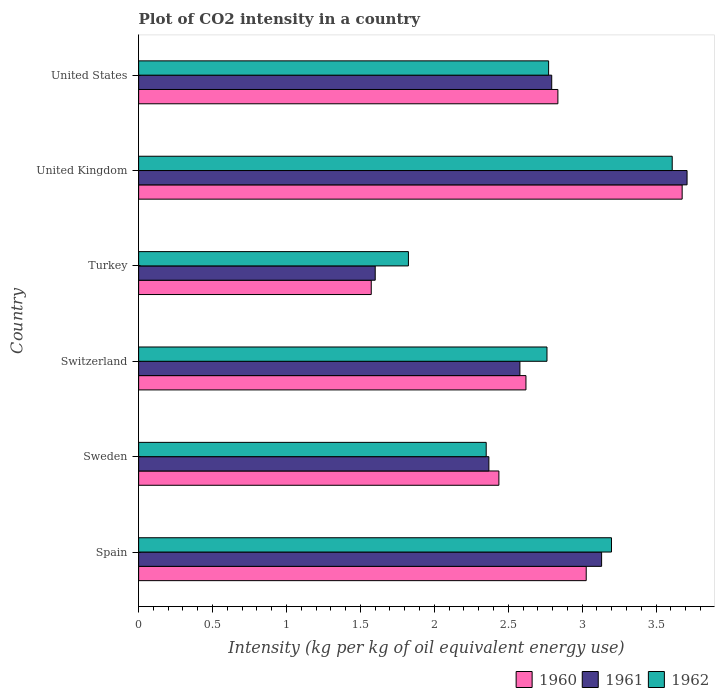How many different coloured bars are there?
Your answer should be very brief. 3. Are the number of bars per tick equal to the number of legend labels?
Offer a very short reply. Yes. Are the number of bars on each tick of the Y-axis equal?
Your response must be concise. Yes. How many bars are there on the 6th tick from the top?
Your answer should be very brief. 3. What is the CO2 intensity in in 1962 in United States?
Offer a very short reply. 2.77. Across all countries, what is the maximum CO2 intensity in in 1962?
Your answer should be very brief. 3.61. Across all countries, what is the minimum CO2 intensity in in 1961?
Provide a succinct answer. 1.6. In which country was the CO2 intensity in in 1961 maximum?
Your answer should be compact. United Kingdom. What is the total CO2 intensity in in 1962 in the graph?
Ensure brevity in your answer.  16.52. What is the difference between the CO2 intensity in in 1961 in Spain and that in United States?
Offer a very short reply. 0.34. What is the difference between the CO2 intensity in in 1960 in United Kingdom and the CO2 intensity in in 1961 in Switzerland?
Your response must be concise. 1.1. What is the average CO2 intensity in in 1961 per country?
Your answer should be very brief. 2.7. What is the difference between the CO2 intensity in in 1961 and CO2 intensity in in 1960 in Switzerland?
Provide a succinct answer. -0.04. In how many countries, is the CO2 intensity in in 1962 greater than 1.7 kg?
Make the answer very short. 6. What is the ratio of the CO2 intensity in in 1962 in Switzerland to that in United States?
Ensure brevity in your answer.  1. Is the CO2 intensity in in 1962 in Switzerland less than that in United States?
Provide a short and direct response. Yes. What is the difference between the highest and the second highest CO2 intensity in in 1961?
Offer a very short reply. 0.58. What is the difference between the highest and the lowest CO2 intensity in in 1960?
Your answer should be very brief. 2.1. In how many countries, is the CO2 intensity in in 1961 greater than the average CO2 intensity in in 1961 taken over all countries?
Ensure brevity in your answer.  3. Is the sum of the CO2 intensity in in 1961 in Sweden and United States greater than the maximum CO2 intensity in in 1960 across all countries?
Offer a very short reply. Yes. What does the 1st bar from the top in Sweden represents?
Provide a short and direct response. 1962. What does the 1st bar from the bottom in United Kingdom represents?
Offer a terse response. 1960. Is it the case that in every country, the sum of the CO2 intensity in in 1962 and CO2 intensity in in 1960 is greater than the CO2 intensity in in 1961?
Provide a succinct answer. Yes. Are all the bars in the graph horizontal?
Provide a short and direct response. Yes. How many countries are there in the graph?
Ensure brevity in your answer.  6. What is the difference between two consecutive major ticks on the X-axis?
Give a very brief answer. 0.5. Are the values on the major ticks of X-axis written in scientific E-notation?
Provide a succinct answer. No. Does the graph contain any zero values?
Offer a very short reply. No. Does the graph contain grids?
Offer a very short reply. No. Where does the legend appear in the graph?
Your answer should be very brief. Bottom right. How many legend labels are there?
Keep it short and to the point. 3. What is the title of the graph?
Your answer should be compact. Plot of CO2 intensity in a country. Does "1981" appear as one of the legend labels in the graph?
Give a very brief answer. No. What is the label or title of the X-axis?
Your response must be concise. Intensity (kg per kg of oil equivalent energy use). What is the Intensity (kg per kg of oil equivalent energy use) of 1960 in Spain?
Ensure brevity in your answer.  3.03. What is the Intensity (kg per kg of oil equivalent energy use) in 1961 in Spain?
Your response must be concise. 3.13. What is the Intensity (kg per kg of oil equivalent energy use) of 1962 in Spain?
Your answer should be very brief. 3.2. What is the Intensity (kg per kg of oil equivalent energy use) in 1960 in Sweden?
Ensure brevity in your answer.  2.44. What is the Intensity (kg per kg of oil equivalent energy use) in 1961 in Sweden?
Keep it short and to the point. 2.37. What is the Intensity (kg per kg of oil equivalent energy use) of 1962 in Sweden?
Your response must be concise. 2.35. What is the Intensity (kg per kg of oil equivalent energy use) in 1960 in Switzerland?
Offer a very short reply. 2.62. What is the Intensity (kg per kg of oil equivalent energy use) in 1961 in Switzerland?
Offer a terse response. 2.58. What is the Intensity (kg per kg of oil equivalent energy use) in 1962 in Switzerland?
Offer a terse response. 2.76. What is the Intensity (kg per kg of oil equivalent energy use) of 1960 in Turkey?
Your response must be concise. 1.57. What is the Intensity (kg per kg of oil equivalent energy use) in 1961 in Turkey?
Offer a very short reply. 1.6. What is the Intensity (kg per kg of oil equivalent energy use) in 1962 in Turkey?
Your answer should be compact. 1.82. What is the Intensity (kg per kg of oil equivalent energy use) in 1960 in United Kingdom?
Offer a terse response. 3.68. What is the Intensity (kg per kg of oil equivalent energy use) in 1961 in United Kingdom?
Your answer should be compact. 3.71. What is the Intensity (kg per kg of oil equivalent energy use) of 1962 in United Kingdom?
Make the answer very short. 3.61. What is the Intensity (kg per kg of oil equivalent energy use) in 1960 in United States?
Your answer should be compact. 2.84. What is the Intensity (kg per kg of oil equivalent energy use) in 1961 in United States?
Provide a succinct answer. 2.79. What is the Intensity (kg per kg of oil equivalent energy use) in 1962 in United States?
Keep it short and to the point. 2.77. Across all countries, what is the maximum Intensity (kg per kg of oil equivalent energy use) in 1960?
Offer a very short reply. 3.68. Across all countries, what is the maximum Intensity (kg per kg of oil equivalent energy use) of 1961?
Your response must be concise. 3.71. Across all countries, what is the maximum Intensity (kg per kg of oil equivalent energy use) in 1962?
Your answer should be compact. 3.61. Across all countries, what is the minimum Intensity (kg per kg of oil equivalent energy use) in 1960?
Provide a short and direct response. 1.57. Across all countries, what is the minimum Intensity (kg per kg of oil equivalent energy use) of 1961?
Keep it short and to the point. 1.6. Across all countries, what is the minimum Intensity (kg per kg of oil equivalent energy use) of 1962?
Ensure brevity in your answer.  1.82. What is the total Intensity (kg per kg of oil equivalent energy use) of 1960 in the graph?
Provide a short and direct response. 16.17. What is the total Intensity (kg per kg of oil equivalent energy use) of 1961 in the graph?
Provide a succinct answer. 16.18. What is the total Intensity (kg per kg of oil equivalent energy use) in 1962 in the graph?
Keep it short and to the point. 16.52. What is the difference between the Intensity (kg per kg of oil equivalent energy use) of 1960 in Spain and that in Sweden?
Provide a succinct answer. 0.59. What is the difference between the Intensity (kg per kg of oil equivalent energy use) in 1961 in Spain and that in Sweden?
Offer a very short reply. 0.76. What is the difference between the Intensity (kg per kg of oil equivalent energy use) in 1962 in Spain and that in Sweden?
Give a very brief answer. 0.85. What is the difference between the Intensity (kg per kg of oil equivalent energy use) in 1960 in Spain and that in Switzerland?
Provide a succinct answer. 0.41. What is the difference between the Intensity (kg per kg of oil equivalent energy use) of 1961 in Spain and that in Switzerland?
Provide a short and direct response. 0.55. What is the difference between the Intensity (kg per kg of oil equivalent energy use) in 1962 in Spain and that in Switzerland?
Keep it short and to the point. 0.44. What is the difference between the Intensity (kg per kg of oil equivalent energy use) of 1960 in Spain and that in Turkey?
Offer a very short reply. 1.45. What is the difference between the Intensity (kg per kg of oil equivalent energy use) of 1961 in Spain and that in Turkey?
Provide a succinct answer. 1.53. What is the difference between the Intensity (kg per kg of oil equivalent energy use) in 1962 in Spain and that in Turkey?
Provide a succinct answer. 1.37. What is the difference between the Intensity (kg per kg of oil equivalent energy use) in 1960 in Spain and that in United Kingdom?
Make the answer very short. -0.65. What is the difference between the Intensity (kg per kg of oil equivalent energy use) of 1961 in Spain and that in United Kingdom?
Keep it short and to the point. -0.58. What is the difference between the Intensity (kg per kg of oil equivalent energy use) of 1962 in Spain and that in United Kingdom?
Your answer should be compact. -0.41. What is the difference between the Intensity (kg per kg of oil equivalent energy use) in 1960 in Spain and that in United States?
Your response must be concise. 0.19. What is the difference between the Intensity (kg per kg of oil equivalent energy use) in 1961 in Spain and that in United States?
Your answer should be compact. 0.34. What is the difference between the Intensity (kg per kg of oil equivalent energy use) in 1962 in Spain and that in United States?
Offer a terse response. 0.43. What is the difference between the Intensity (kg per kg of oil equivalent energy use) of 1960 in Sweden and that in Switzerland?
Give a very brief answer. -0.18. What is the difference between the Intensity (kg per kg of oil equivalent energy use) of 1961 in Sweden and that in Switzerland?
Offer a terse response. -0.21. What is the difference between the Intensity (kg per kg of oil equivalent energy use) in 1962 in Sweden and that in Switzerland?
Your answer should be compact. -0.41. What is the difference between the Intensity (kg per kg of oil equivalent energy use) of 1960 in Sweden and that in Turkey?
Keep it short and to the point. 0.86. What is the difference between the Intensity (kg per kg of oil equivalent energy use) in 1961 in Sweden and that in Turkey?
Your answer should be compact. 0.77. What is the difference between the Intensity (kg per kg of oil equivalent energy use) of 1962 in Sweden and that in Turkey?
Offer a terse response. 0.53. What is the difference between the Intensity (kg per kg of oil equivalent energy use) of 1960 in Sweden and that in United Kingdom?
Keep it short and to the point. -1.24. What is the difference between the Intensity (kg per kg of oil equivalent energy use) in 1961 in Sweden and that in United Kingdom?
Offer a terse response. -1.34. What is the difference between the Intensity (kg per kg of oil equivalent energy use) in 1962 in Sweden and that in United Kingdom?
Give a very brief answer. -1.26. What is the difference between the Intensity (kg per kg of oil equivalent energy use) of 1960 in Sweden and that in United States?
Your answer should be very brief. -0.4. What is the difference between the Intensity (kg per kg of oil equivalent energy use) of 1961 in Sweden and that in United States?
Your answer should be very brief. -0.43. What is the difference between the Intensity (kg per kg of oil equivalent energy use) of 1962 in Sweden and that in United States?
Ensure brevity in your answer.  -0.42. What is the difference between the Intensity (kg per kg of oil equivalent energy use) of 1960 in Switzerland and that in Turkey?
Make the answer very short. 1.05. What is the difference between the Intensity (kg per kg of oil equivalent energy use) of 1961 in Switzerland and that in Turkey?
Your response must be concise. 0.98. What is the difference between the Intensity (kg per kg of oil equivalent energy use) of 1962 in Switzerland and that in Turkey?
Your response must be concise. 0.94. What is the difference between the Intensity (kg per kg of oil equivalent energy use) in 1960 in Switzerland and that in United Kingdom?
Offer a terse response. -1.06. What is the difference between the Intensity (kg per kg of oil equivalent energy use) in 1961 in Switzerland and that in United Kingdom?
Your answer should be very brief. -1.13. What is the difference between the Intensity (kg per kg of oil equivalent energy use) in 1962 in Switzerland and that in United Kingdom?
Offer a terse response. -0.85. What is the difference between the Intensity (kg per kg of oil equivalent energy use) in 1960 in Switzerland and that in United States?
Ensure brevity in your answer.  -0.22. What is the difference between the Intensity (kg per kg of oil equivalent energy use) in 1961 in Switzerland and that in United States?
Provide a short and direct response. -0.22. What is the difference between the Intensity (kg per kg of oil equivalent energy use) in 1962 in Switzerland and that in United States?
Provide a short and direct response. -0.01. What is the difference between the Intensity (kg per kg of oil equivalent energy use) in 1960 in Turkey and that in United Kingdom?
Offer a terse response. -2.1. What is the difference between the Intensity (kg per kg of oil equivalent energy use) in 1961 in Turkey and that in United Kingdom?
Make the answer very short. -2.11. What is the difference between the Intensity (kg per kg of oil equivalent energy use) of 1962 in Turkey and that in United Kingdom?
Offer a very short reply. -1.78. What is the difference between the Intensity (kg per kg of oil equivalent energy use) of 1960 in Turkey and that in United States?
Your answer should be very brief. -1.26. What is the difference between the Intensity (kg per kg of oil equivalent energy use) of 1961 in Turkey and that in United States?
Your response must be concise. -1.19. What is the difference between the Intensity (kg per kg of oil equivalent energy use) of 1962 in Turkey and that in United States?
Offer a terse response. -0.95. What is the difference between the Intensity (kg per kg of oil equivalent energy use) of 1960 in United Kingdom and that in United States?
Ensure brevity in your answer.  0.84. What is the difference between the Intensity (kg per kg of oil equivalent energy use) of 1961 in United Kingdom and that in United States?
Your response must be concise. 0.92. What is the difference between the Intensity (kg per kg of oil equivalent energy use) of 1962 in United Kingdom and that in United States?
Offer a very short reply. 0.84. What is the difference between the Intensity (kg per kg of oil equivalent energy use) of 1960 in Spain and the Intensity (kg per kg of oil equivalent energy use) of 1961 in Sweden?
Offer a very short reply. 0.66. What is the difference between the Intensity (kg per kg of oil equivalent energy use) of 1960 in Spain and the Intensity (kg per kg of oil equivalent energy use) of 1962 in Sweden?
Make the answer very short. 0.68. What is the difference between the Intensity (kg per kg of oil equivalent energy use) in 1961 in Spain and the Intensity (kg per kg of oil equivalent energy use) in 1962 in Sweden?
Provide a succinct answer. 0.78. What is the difference between the Intensity (kg per kg of oil equivalent energy use) of 1960 in Spain and the Intensity (kg per kg of oil equivalent energy use) of 1961 in Switzerland?
Offer a very short reply. 0.45. What is the difference between the Intensity (kg per kg of oil equivalent energy use) of 1960 in Spain and the Intensity (kg per kg of oil equivalent energy use) of 1962 in Switzerland?
Your response must be concise. 0.27. What is the difference between the Intensity (kg per kg of oil equivalent energy use) of 1961 in Spain and the Intensity (kg per kg of oil equivalent energy use) of 1962 in Switzerland?
Make the answer very short. 0.37. What is the difference between the Intensity (kg per kg of oil equivalent energy use) in 1960 in Spain and the Intensity (kg per kg of oil equivalent energy use) in 1961 in Turkey?
Your response must be concise. 1.43. What is the difference between the Intensity (kg per kg of oil equivalent energy use) of 1960 in Spain and the Intensity (kg per kg of oil equivalent energy use) of 1962 in Turkey?
Keep it short and to the point. 1.2. What is the difference between the Intensity (kg per kg of oil equivalent energy use) in 1961 in Spain and the Intensity (kg per kg of oil equivalent energy use) in 1962 in Turkey?
Your answer should be very brief. 1.31. What is the difference between the Intensity (kg per kg of oil equivalent energy use) of 1960 in Spain and the Intensity (kg per kg of oil equivalent energy use) of 1961 in United Kingdom?
Give a very brief answer. -0.68. What is the difference between the Intensity (kg per kg of oil equivalent energy use) in 1960 in Spain and the Intensity (kg per kg of oil equivalent energy use) in 1962 in United Kingdom?
Your answer should be compact. -0.58. What is the difference between the Intensity (kg per kg of oil equivalent energy use) of 1961 in Spain and the Intensity (kg per kg of oil equivalent energy use) of 1962 in United Kingdom?
Provide a short and direct response. -0.48. What is the difference between the Intensity (kg per kg of oil equivalent energy use) of 1960 in Spain and the Intensity (kg per kg of oil equivalent energy use) of 1961 in United States?
Provide a short and direct response. 0.23. What is the difference between the Intensity (kg per kg of oil equivalent energy use) of 1960 in Spain and the Intensity (kg per kg of oil equivalent energy use) of 1962 in United States?
Offer a terse response. 0.25. What is the difference between the Intensity (kg per kg of oil equivalent energy use) in 1961 in Spain and the Intensity (kg per kg of oil equivalent energy use) in 1962 in United States?
Provide a succinct answer. 0.36. What is the difference between the Intensity (kg per kg of oil equivalent energy use) in 1960 in Sweden and the Intensity (kg per kg of oil equivalent energy use) in 1961 in Switzerland?
Your answer should be very brief. -0.14. What is the difference between the Intensity (kg per kg of oil equivalent energy use) in 1960 in Sweden and the Intensity (kg per kg of oil equivalent energy use) in 1962 in Switzerland?
Ensure brevity in your answer.  -0.33. What is the difference between the Intensity (kg per kg of oil equivalent energy use) of 1961 in Sweden and the Intensity (kg per kg of oil equivalent energy use) of 1962 in Switzerland?
Your response must be concise. -0.39. What is the difference between the Intensity (kg per kg of oil equivalent energy use) of 1960 in Sweden and the Intensity (kg per kg of oil equivalent energy use) of 1961 in Turkey?
Provide a short and direct response. 0.84. What is the difference between the Intensity (kg per kg of oil equivalent energy use) in 1960 in Sweden and the Intensity (kg per kg of oil equivalent energy use) in 1962 in Turkey?
Your response must be concise. 0.61. What is the difference between the Intensity (kg per kg of oil equivalent energy use) in 1961 in Sweden and the Intensity (kg per kg of oil equivalent energy use) in 1962 in Turkey?
Offer a very short reply. 0.54. What is the difference between the Intensity (kg per kg of oil equivalent energy use) in 1960 in Sweden and the Intensity (kg per kg of oil equivalent energy use) in 1961 in United Kingdom?
Give a very brief answer. -1.27. What is the difference between the Intensity (kg per kg of oil equivalent energy use) in 1960 in Sweden and the Intensity (kg per kg of oil equivalent energy use) in 1962 in United Kingdom?
Your answer should be compact. -1.17. What is the difference between the Intensity (kg per kg of oil equivalent energy use) of 1961 in Sweden and the Intensity (kg per kg of oil equivalent energy use) of 1962 in United Kingdom?
Offer a very short reply. -1.24. What is the difference between the Intensity (kg per kg of oil equivalent energy use) of 1960 in Sweden and the Intensity (kg per kg of oil equivalent energy use) of 1961 in United States?
Keep it short and to the point. -0.36. What is the difference between the Intensity (kg per kg of oil equivalent energy use) of 1960 in Sweden and the Intensity (kg per kg of oil equivalent energy use) of 1962 in United States?
Your answer should be very brief. -0.34. What is the difference between the Intensity (kg per kg of oil equivalent energy use) in 1961 in Sweden and the Intensity (kg per kg of oil equivalent energy use) in 1962 in United States?
Offer a very short reply. -0.4. What is the difference between the Intensity (kg per kg of oil equivalent energy use) of 1960 in Switzerland and the Intensity (kg per kg of oil equivalent energy use) of 1961 in Turkey?
Provide a short and direct response. 1.02. What is the difference between the Intensity (kg per kg of oil equivalent energy use) of 1960 in Switzerland and the Intensity (kg per kg of oil equivalent energy use) of 1962 in Turkey?
Your answer should be compact. 0.8. What is the difference between the Intensity (kg per kg of oil equivalent energy use) in 1961 in Switzerland and the Intensity (kg per kg of oil equivalent energy use) in 1962 in Turkey?
Offer a terse response. 0.75. What is the difference between the Intensity (kg per kg of oil equivalent energy use) in 1960 in Switzerland and the Intensity (kg per kg of oil equivalent energy use) in 1961 in United Kingdom?
Offer a terse response. -1.09. What is the difference between the Intensity (kg per kg of oil equivalent energy use) in 1960 in Switzerland and the Intensity (kg per kg of oil equivalent energy use) in 1962 in United Kingdom?
Offer a terse response. -0.99. What is the difference between the Intensity (kg per kg of oil equivalent energy use) in 1961 in Switzerland and the Intensity (kg per kg of oil equivalent energy use) in 1962 in United Kingdom?
Your answer should be compact. -1.03. What is the difference between the Intensity (kg per kg of oil equivalent energy use) in 1960 in Switzerland and the Intensity (kg per kg of oil equivalent energy use) in 1961 in United States?
Give a very brief answer. -0.17. What is the difference between the Intensity (kg per kg of oil equivalent energy use) in 1960 in Switzerland and the Intensity (kg per kg of oil equivalent energy use) in 1962 in United States?
Provide a succinct answer. -0.15. What is the difference between the Intensity (kg per kg of oil equivalent energy use) in 1961 in Switzerland and the Intensity (kg per kg of oil equivalent energy use) in 1962 in United States?
Provide a short and direct response. -0.19. What is the difference between the Intensity (kg per kg of oil equivalent energy use) of 1960 in Turkey and the Intensity (kg per kg of oil equivalent energy use) of 1961 in United Kingdom?
Provide a succinct answer. -2.14. What is the difference between the Intensity (kg per kg of oil equivalent energy use) of 1960 in Turkey and the Intensity (kg per kg of oil equivalent energy use) of 1962 in United Kingdom?
Provide a short and direct response. -2.04. What is the difference between the Intensity (kg per kg of oil equivalent energy use) in 1961 in Turkey and the Intensity (kg per kg of oil equivalent energy use) in 1962 in United Kingdom?
Ensure brevity in your answer.  -2.01. What is the difference between the Intensity (kg per kg of oil equivalent energy use) of 1960 in Turkey and the Intensity (kg per kg of oil equivalent energy use) of 1961 in United States?
Keep it short and to the point. -1.22. What is the difference between the Intensity (kg per kg of oil equivalent energy use) of 1960 in Turkey and the Intensity (kg per kg of oil equivalent energy use) of 1962 in United States?
Ensure brevity in your answer.  -1.2. What is the difference between the Intensity (kg per kg of oil equivalent energy use) in 1961 in Turkey and the Intensity (kg per kg of oil equivalent energy use) in 1962 in United States?
Offer a terse response. -1.17. What is the difference between the Intensity (kg per kg of oil equivalent energy use) of 1960 in United Kingdom and the Intensity (kg per kg of oil equivalent energy use) of 1961 in United States?
Offer a terse response. 0.88. What is the difference between the Intensity (kg per kg of oil equivalent energy use) of 1960 in United Kingdom and the Intensity (kg per kg of oil equivalent energy use) of 1962 in United States?
Offer a very short reply. 0.9. What is the difference between the Intensity (kg per kg of oil equivalent energy use) in 1961 in United Kingdom and the Intensity (kg per kg of oil equivalent energy use) in 1962 in United States?
Keep it short and to the point. 0.94. What is the average Intensity (kg per kg of oil equivalent energy use) of 1960 per country?
Give a very brief answer. 2.69. What is the average Intensity (kg per kg of oil equivalent energy use) in 1961 per country?
Offer a very short reply. 2.7. What is the average Intensity (kg per kg of oil equivalent energy use) in 1962 per country?
Ensure brevity in your answer.  2.75. What is the difference between the Intensity (kg per kg of oil equivalent energy use) in 1960 and Intensity (kg per kg of oil equivalent energy use) in 1961 in Spain?
Offer a very short reply. -0.1. What is the difference between the Intensity (kg per kg of oil equivalent energy use) in 1960 and Intensity (kg per kg of oil equivalent energy use) in 1962 in Spain?
Offer a very short reply. -0.17. What is the difference between the Intensity (kg per kg of oil equivalent energy use) in 1961 and Intensity (kg per kg of oil equivalent energy use) in 1962 in Spain?
Offer a very short reply. -0.07. What is the difference between the Intensity (kg per kg of oil equivalent energy use) of 1960 and Intensity (kg per kg of oil equivalent energy use) of 1961 in Sweden?
Provide a succinct answer. 0.07. What is the difference between the Intensity (kg per kg of oil equivalent energy use) in 1960 and Intensity (kg per kg of oil equivalent energy use) in 1962 in Sweden?
Your answer should be compact. 0.09. What is the difference between the Intensity (kg per kg of oil equivalent energy use) of 1961 and Intensity (kg per kg of oil equivalent energy use) of 1962 in Sweden?
Ensure brevity in your answer.  0.02. What is the difference between the Intensity (kg per kg of oil equivalent energy use) of 1960 and Intensity (kg per kg of oil equivalent energy use) of 1961 in Switzerland?
Offer a terse response. 0.04. What is the difference between the Intensity (kg per kg of oil equivalent energy use) of 1960 and Intensity (kg per kg of oil equivalent energy use) of 1962 in Switzerland?
Your answer should be very brief. -0.14. What is the difference between the Intensity (kg per kg of oil equivalent energy use) in 1961 and Intensity (kg per kg of oil equivalent energy use) in 1962 in Switzerland?
Keep it short and to the point. -0.18. What is the difference between the Intensity (kg per kg of oil equivalent energy use) in 1960 and Intensity (kg per kg of oil equivalent energy use) in 1961 in Turkey?
Your response must be concise. -0.03. What is the difference between the Intensity (kg per kg of oil equivalent energy use) in 1960 and Intensity (kg per kg of oil equivalent energy use) in 1962 in Turkey?
Make the answer very short. -0.25. What is the difference between the Intensity (kg per kg of oil equivalent energy use) in 1961 and Intensity (kg per kg of oil equivalent energy use) in 1962 in Turkey?
Provide a succinct answer. -0.22. What is the difference between the Intensity (kg per kg of oil equivalent energy use) of 1960 and Intensity (kg per kg of oil equivalent energy use) of 1961 in United Kingdom?
Provide a succinct answer. -0.03. What is the difference between the Intensity (kg per kg of oil equivalent energy use) in 1960 and Intensity (kg per kg of oil equivalent energy use) in 1962 in United Kingdom?
Your answer should be compact. 0.07. What is the difference between the Intensity (kg per kg of oil equivalent energy use) in 1961 and Intensity (kg per kg of oil equivalent energy use) in 1962 in United Kingdom?
Provide a succinct answer. 0.1. What is the difference between the Intensity (kg per kg of oil equivalent energy use) of 1960 and Intensity (kg per kg of oil equivalent energy use) of 1961 in United States?
Provide a short and direct response. 0.04. What is the difference between the Intensity (kg per kg of oil equivalent energy use) of 1960 and Intensity (kg per kg of oil equivalent energy use) of 1962 in United States?
Your answer should be very brief. 0.06. What is the difference between the Intensity (kg per kg of oil equivalent energy use) of 1961 and Intensity (kg per kg of oil equivalent energy use) of 1962 in United States?
Ensure brevity in your answer.  0.02. What is the ratio of the Intensity (kg per kg of oil equivalent energy use) in 1960 in Spain to that in Sweden?
Keep it short and to the point. 1.24. What is the ratio of the Intensity (kg per kg of oil equivalent energy use) in 1961 in Spain to that in Sweden?
Give a very brief answer. 1.32. What is the ratio of the Intensity (kg per kg of oil equivalent energy use) of 1962 in Spain to that in Sweden?
Ensure brevity in your answer.  1.36. What is the ratio of the Intensity (kg per kg of oil equivalent energy use) of 1960 in Spain to that in Switzerland?
Give a very brief answer. 1.16. What is the ratio of the Intensity (kg per kg of oil equivalent energy use) of 1961 in Spain to that in Switzerland?
Your response must be concise. 1.21. What is the ratio of the Intensity (kg per kg of oil equivalent energy use) in 1962 in Spain to that in Switzerland?
Your response must be concise. 1.16. What is the ratio of the Intensity (kg per kg of oil equivalent energy use) in 1960 in Spain to that in Turkey?
Give a very brief answer. 1.92. What is the ratio of the Intensity (kg per kg of oil equivalent energy use) of 1961 in Spain to that in Turkey?
Offer a terse response. 1.96. What is the ratio of the Intensity (kg per kg of oil equivalent energy use) in 1962 in Spain to that in Turkey?
Your answer should be very brief. 1.75. What is the ratio of the Intensity (kg per kg of oil equivalent energy use) in 1960 in Spain to that in United Kingdom?
Give a very brief answer. 0.82. What is the ratio of the Intensity (kg per kg of oil equivalent energy use) of 1961 in Spain to that in United Kingdom?
Keep it short and to the point. 0.84. What is the ratio of the Intensity (kg per kg of oil equivalent energy use) of 1962 in Spain to that in United Kingdom?
Your response must be concise. 0.89. What is the ratio of the Intensity (kg per kg of oil equivalent energy use) of 1960 in Spain to that in United States?
Your answer should be very brief. 1.07. What is the ratio of the Intensity (kg per kg of oil equivalent energy use) in 1961 in Spain to that in United States?
Your answer should be very brief. 1.12. What is the ratio of the Intensity (kg per kg of oil equivalent energy use) in 1962 in Spain to that in United States?
Offer a terse response. 1.15. What is the ratio of the Intensity (kg per kg of oil equivalent energy use) of 1960 in Sweden to that in Switzerland?
Offer a very short reply. 0.93. What is the ratio of the Intensity (kg per kg of oil equivalent energy use) in 1961 in Sweden to that in Switzerland?
Offer a terse response. 0.92. What is the ratio of the Intensity (kg per kg of oil equivalent energy use) in 1962 in Sweden to that in Switzerland?
Keep it short and to the point. 0.85. What is the ratio of the Intensity (kg per kg of oil equivalent energy use) in 1960 in Sweden to that in Turkey?
Make the answer very short. 1.55. What is the ratio of the Intensity (kg per kg of oil equivalent energy use) in 1961 in Sweden to that in Turkey?
Your response must be concise. 1.48. What is the ratio of the Intensity (kg per kg of oil equivalent energy use) in 1962 in Sweden to that in Turkey?
Ensure brevity in your answer.  1.29. What is the ratio of the Intensity (kg per kg of oil equivalent energy use) of 1960 in Sweden to that in United Kingdom?
Offer a terse response. 0.66. What is the ratio of the Intensity (kg per kg of oil equivalent energy use) of 1961 in Sweden to that in United Kingdom?
Ensure brevity in your answer.  0.64. What is the ratio of the Intensity (kg per kg of oil equivalent energy use) in 1962 in Sweden to that in United Kingdom?
Ensure brevity in your answer.  0.65. What is the ratio of the Intensity (kg per kg of oil equivalent energy use) of 1960 in Sweden to that in United States?
Give a very brief answer. 0.86. What is the ratio of the Intensity (kg per kg of oil equivalent energy use) in 1961 in Sweden to that in United States?
Provide a succinct answer. 0.85. What is the ratio of the Intensity (kg per kg of oil equivalent energy use) of 1962 in Sweden to that in United States?
Your answer should be compact. 0.85. What is the ratio of the Intensity (kg per kg of oil equivalent energy use) in 1960 in Switzerland to that in Turkey?
Your response must be concise. 1.67. What is the ratio of the Intensity (kg per kg of oil equivalent energy use) in 1961 in Switzerland to that in Turkey?
Ensure brevity in your answer.  1.61. What is the ratio of the Intensity (kg per kg of oil equivalent energy use) in 1962 in Switzerland to that in Turkey?
Provide a succinct answer. 1.51. What is the ratio of the Intensity (kg per kg of oil equivalent energy use) of 1960 in Switzerland to that in United Kingdom?
Offer a terse response. 0.71. What is the ratio of the Intensity (kg per kg of oil equivalent energy use) in 1961 in Switzerland to that in United Kingdom?
Your response must be concise. 0.7. What is the ratio of the Intensity (kg per kg of oil equivalent energy use) in 1962 in Switzerland to that in United Kingdom?
Your answer should be very brief. 0.77. What is the ratio of the Intensity (kg per kg of oil equivalent energy use) in 1960 in Switzerland to that in United States?
Provide a succinct answer. 0.92. What is the ratio of the Intensity (kg per kg of oil equivalent energy use) of 1961 in Switzerland to that in United States?
Provide a short and direct response. 0.92. What is the ratio of the Intensity (kg per kg of oil equivalent energy use) of 1960 in Turkey to that in United Kingdom?
Offer a very short reply. 0.43. What is the ratio of the Intensity (kg per kg of oil equivalent energy use) of 1961 in Turkey to that in United Kingdom?
Offer a terse response. 0.43. What is the ratio of the Intensity (kg per kg of oil equivalent energy use) in 1962 in Turkey to that in United Kingdom?
Your response must be concise. 0.51. What is the ratio of the Intensity (kg per kg of oil equivalent energy use) in 1960 in Turkey to that in United States?
Your answer should be compact. 0.55. What is the ratio of the Intensity (kg per kg of oil equivalent energy use) in 1961 in Turkey to that in United States?
Offer a very short reply. 0.57. What is the ratio of the Intensity (kg per kg of oil equivalent energy use) of 1962 in Turkey to that in United States?
Offer a very short reply. 0.66. What is the ratio of the Intensity (kg per kg of oil equivalent energy use) of 1960 in United Kingdom to that in United States?
Keep it short and to the point. 1.3. What is the ratio of the Intensity (kg per kg of oil equivalent energy use) of 1961 in United Kingdom to that in United States?
Your answer should be very brief. 1.33. What is the ratio of the Intensity (kg per kg of oil equivalent energy use) in 1962 in United Kingdom to that in United States?
Give a very brief answer. 1.3. What is the difference between the highest and the second highest Intensity (kg per kg of oil equivalent energy use) in 1960?
Offer a terse response. 0.65. What is the difference between the highest and the second highest Intensity (kg per kg of oil equivalent energy use) in 1961?
Your response must be concise. 0.58. What is the difference between the highest and the second highest Intensity (kg per kg of oil equivalent energy use) in 1962?
Make the answer very short. 0.41. What is the difference between the highest and the lowest Intensity (kg per kg of oil equivalent energy use) in 1960?
Your response must be concise. 2.1. What is the difference between the highest and the lowest Intensity (kg per kg of oil equivalent energy use) of 1961?
Offer a very short reply. 2.11. What is the difference between the highest and the lowest Intensity (kg per kg of oil equivalent energy use) of 1962?
Make the answer very short. 1.78. 